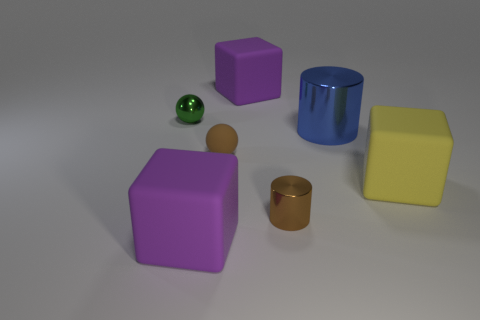There is another tiny thing that is the same color as the small matte object; what is its shape?
Offer a very short reply. Cylinder. How many other small brown objects have the same shape as the brown shiny object?
Make the answer very short. 0. What size is the yellow thing that is the same material as the brown sphere?
Your answer should be compact. Large. Is the brown ball the same size as the brown metal cylinder?
Make the answer very short. Yes. Is there a small green ball?
Keep it short and to the point. Yes. There is a shiny thing that is the same color as the tiny matte object; what is its size?
Keep it short and to the point. Small. How big is the matte thing that is right of the purple block to the right of the large purple rubber object in front of the yellow rubber object?
Your response must be concise. Large. How many blue cylinders have the same material as the yellow object?
Keep it short and to the point. 0. How many metallic objects have the same size as the green ball?
Offer a very short reply. 1. The big purple cube behind the purple thing in front of the big cylinder that is in front of the tiny metallic ball is made of what material?
Your answer should be compact. Rubber. 